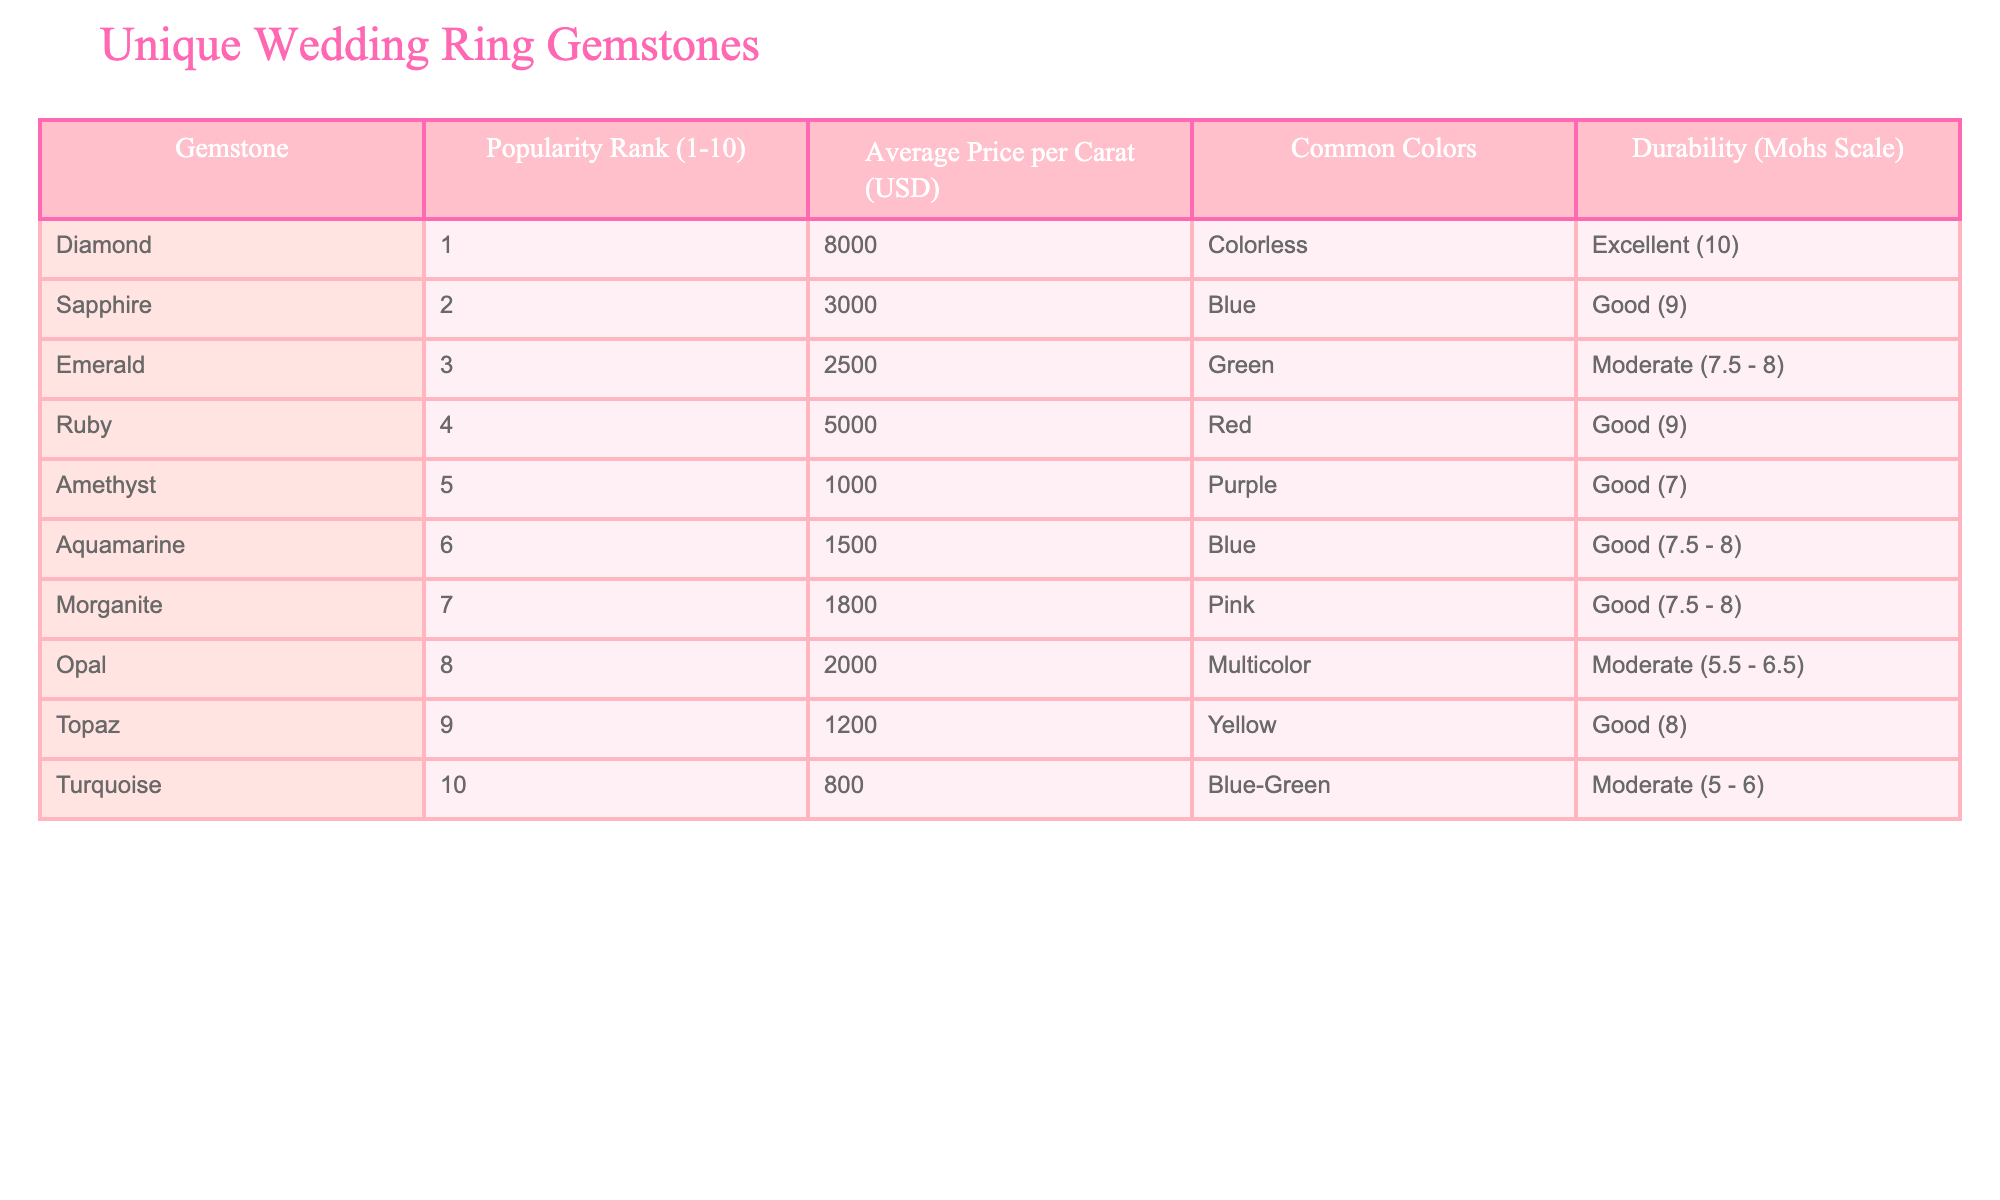What is the average price per carat of a Sapphire? The average price per carat is found in the column that corresponds to Sapphire, which lists it as 3000 USD.
Answer: 3000 USD Which gemstone has the highest durability according to the Mohs scale? The Mohs scale durability column shows that Diamond has a rating of 10, which is the highest among all listed gemstones.
Answer: Diamond What is the popularity rank of Opal? The popularity rank is directly retrieved from the first column where Opal is ranked number 8.
Answer: 8 If we consider the average price of the two most popular gemstones (Diamond and Sapphire), what would that average be? The average price is calculated by adding the prices of Diamond (8000 USD) and Sapphire (3000 USD) and dividing by 2: (8000 + 3000)/2 = 5500.
Answer: 5500 USD Is Ruby more expensive than Emerald? The average price per carat for Ruby is 5000 USD and for Emerald, it is 2500 USD. Since 5000 USD is greater than 2500 USD, the answer is yes.
Answer: Yes Which gemstones are categorized as having 'Good' durability according to the table? By filtering the durability column, we find that the gemstones with 'Good' durability include Sapphire, Ruby, Amethyst, Aquamarine, Morganite, and Topaz.
Answer: Sapphire, Ruby, Amethyst, Aquamarine, Morganite, Topaz What is the price difference between the most and least popular gemstones? The price difference can be calculated by taking the price of the most popular gemstone, Diamond (8000 USD), and subtracting the price of the least popular gemstone, Turquoise (800 USD). Thus, the difference is 8000 - 800 = 7200 USD.
Answer: 7200 USD What color is associated with Morganite? The common color for Morganite, as provided in the table, is Pink.
Answer: Pink How many gemstones have an average price below 2000 USD? By examining the average prices, the gemstones that fall below 2000 USD are Amethyst (1000), Aquamarine (1500), Morganite (1800), and Turquoise (800). This totals to 4 gemstones.
Answer: 4 